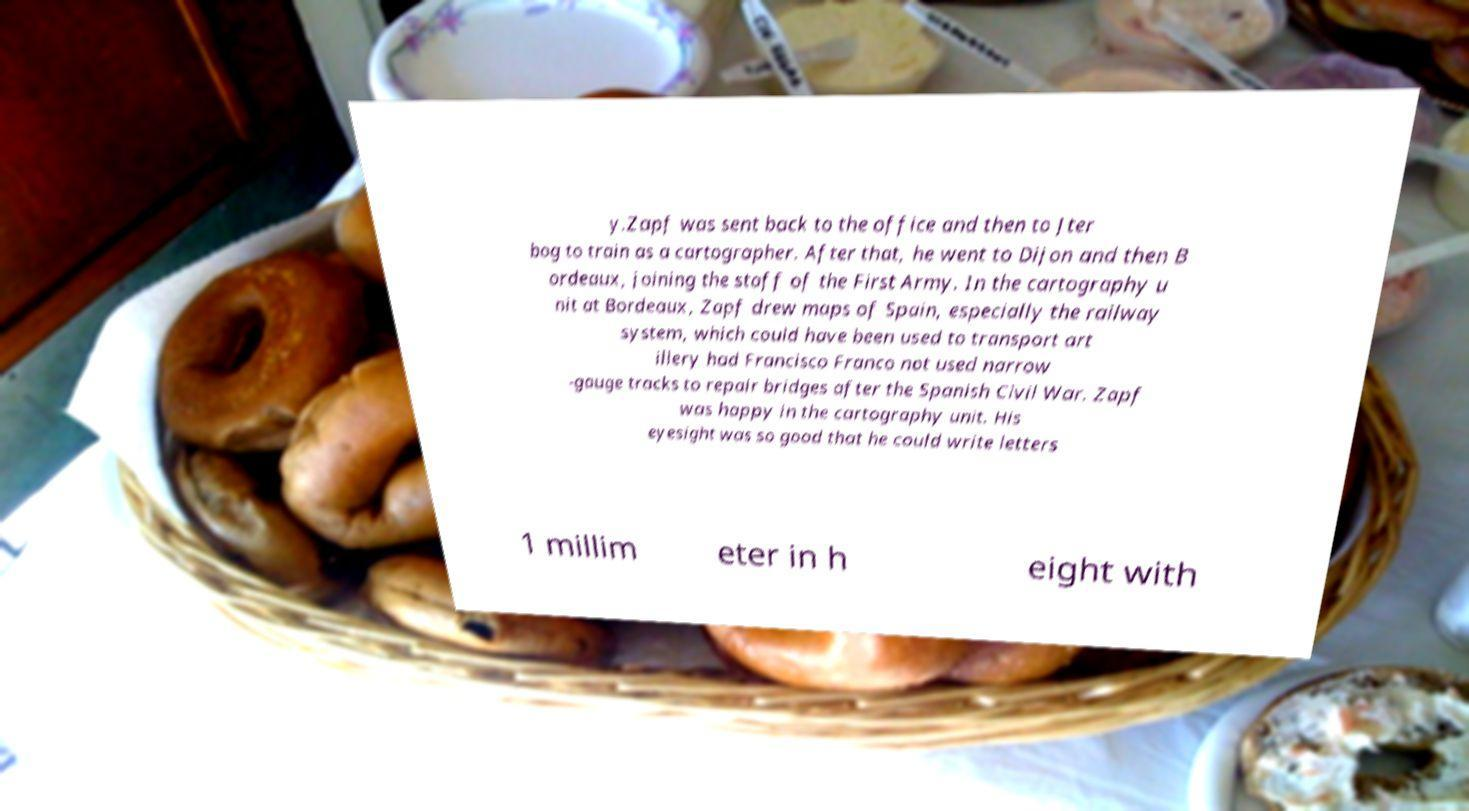Can you read and provide the text displayed in the image?This photo seems to have some interesting text. Can you extract and type it out for me? y.Zapf was sent back to the office and then to Jter bog to train as a cartographer. After that, he went to Dijon and then B ordeaux, joining the staff of the First Army. In the cartography u nit at Bordeaux, Zapf drew maps of Spain, especially the railway system, which could have been used to transport art illery had Francisco Franco not used narrow -gauge tracks to repair bridges after the Spanish Civil War. Zapf was happy in the cartography unit. His eyesight was so good that he could write letters 1 millim eter in h eight with 